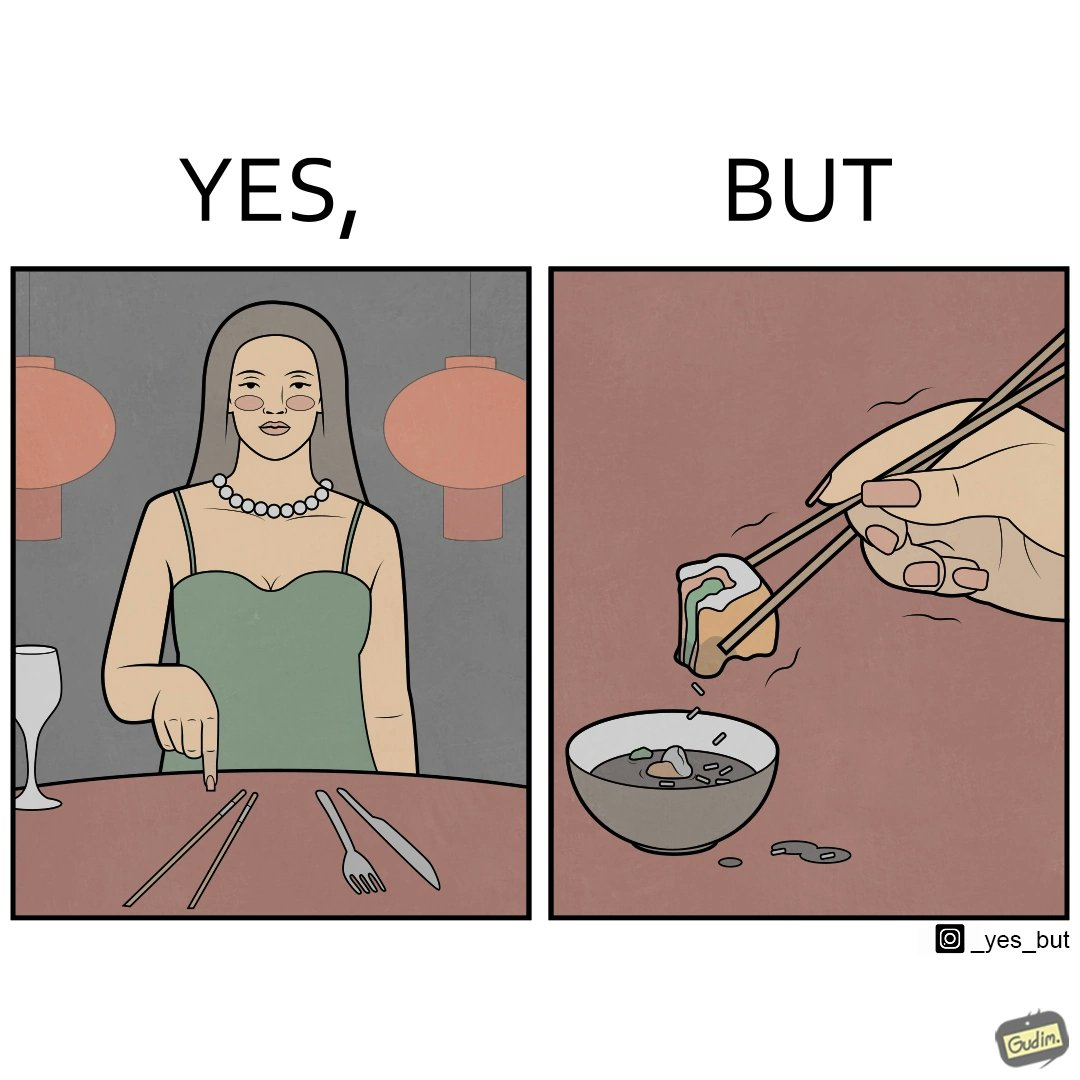Describe the contrast between the left and right parts of this image. In the left part of the image: The image shows a woman sitting at a table in a restaruant pointing to chopsticks on her table. There is also a wine glass, a fork and a knief on her table. In the right part of the image: The image shows a person using chopstick to pick up food from the cup. The person is not able to handle food with chopstick well and is dropping the food around the cup on the table. 